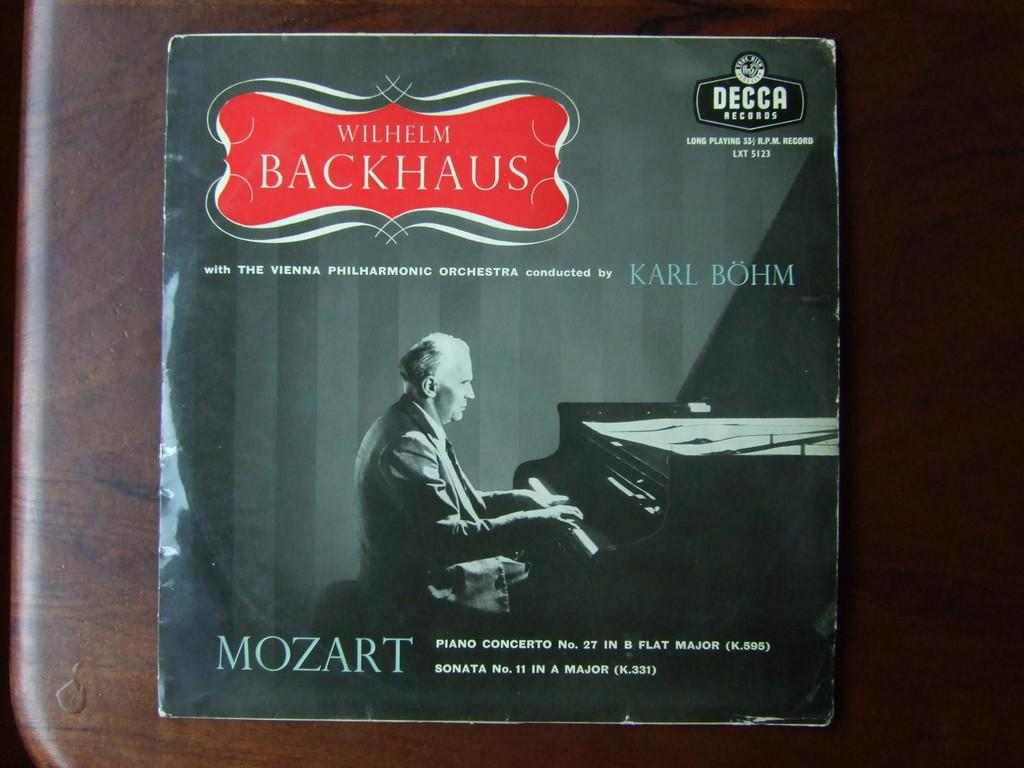Provide a one-sentence caption for the provided image. A man sits at a piano under the name Wilhelm Backhaus. 